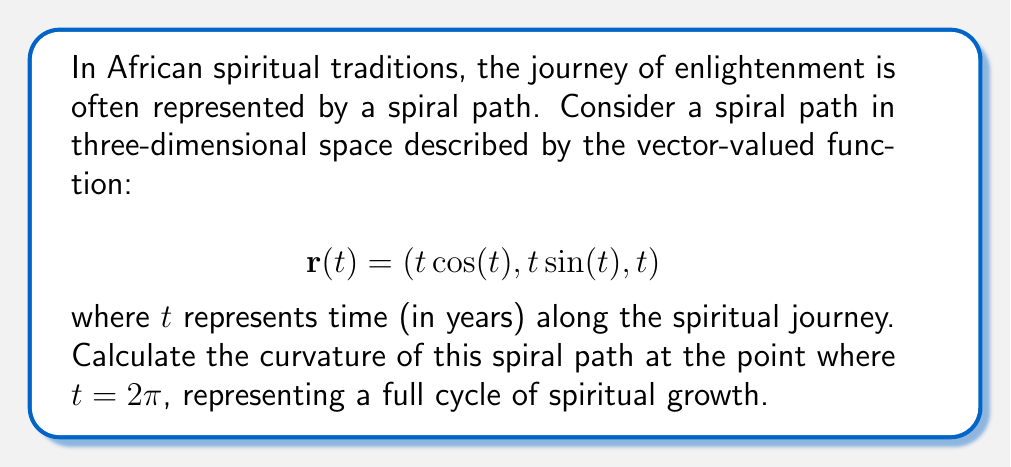Can you answer this question? To calculate the curvature of the spiral path, we'll follow these steps:

1) First, we need to find $\mathbf{r}'(t)$ and $\mathbf{r}''(t)$:

   $$\mathbf{r}'(t) = (\cos(t) - t\sin(t), \sin(t) + t\cos(t), 1)$$
   $$\mathbf{r}''(t) = (-2\sin(t) - t\cos(t), 2\cos(t) - t\sin(t), 0)$$

2) The formula for curvature is:

   $$\kappa = \frac{|\mathbf{r}'(t) \times \mathbf{r}''(t)|}{|\mathbf{r}'(t)|^3}$$

3) Let's calculate $\mathbf{r}'(t) \times \mathbf{r}''(t)$:

   $$\mathbf{r}'(t) \times \mathbf{r}''(t) = \begin{vmatrix} 
   \mathbf{i} & \mathbf{j} & \mathbf{k} \\
   \cos(t) - t\sin(t) & \sin(t) + t\cos(t) & 1 \\
   -2\sin(t) - t\cos(t) & 2\cos(t) - t\sin(t) & 0
   \end{vmatrix}$$

   $$= ((2\cos(t) - t\sin(t)) - (\sin(t) + t\cos(t))(0))\mathbf{i} + ((-2\sin(t) - t\cos(t)) - (\cos(t) - t\sin(t))(0))\mathbf{j} + ((\cos(t) - t\sin(t))(2\cos(t) - t\sin(t)) - (\sin(t) + t\cos(t))(-2\sin(t) - t\cos(t)))\mathbf{k}$$

   $$= (2\cos(t) - t\sin(t))\mathbf{i} + (-2\sin(t) - t\cos(t))\mathbf{j} + (2\cos^2(t) - t\sin(t)\cos(t) + 2\sin^2(t) + t\sin(t)\cos(t))\mathbf{k}$$

   $$= (2\cos(t) - t\sin(t))\mathbf{i} + (-2\sin(t) - t\cos(t))\mathbf{j} + 2\mathbf{k}$$

4) The magnitude of this cross product is:

   $$|\mathbf{r}'(t) \times \mathbf{r}''(t)| = \sqrt{(2\cos(t) - t\sin(t))^2 + (-2\sin(t) - t\cos(t))^2 + 4}$$

5) Now, let's calculate $|\mathbf{r}'(t)|$:

   $$|\mathbf{r}'(t)| = \sqrt{(\cos(t) - t\sin(t))^2 + (\sin(t) + t\cos(t))^2 + 1}$$

6) At $t = 2\pi$:

   $$|\mathbf{r}'(2\pi) \times \mathbf{r}''(2\pi)| = \sqrt{(2 - 2\pi(0))^2 + (0 - 2\pi(1))^2 + 4} = \sqrt{4 + 4\pi^2 + 4} = \sqrt{4\pi^2 + 8}$$

   $$|\mathbf{r}'(2\pi)| = \sqrt{(1 - 2\pi(0))^2 + (0 + 2\pi(1))^2 + 1} = \sqrt{1 + 4\pi^2 + 1} = \sqrt{4\pi^2 + 2}$$

7) Therefore, the curvature at $t = 2\pi$ is:

   $$\kappa = \frac{\sqrt{4\pi^2 + 8}}{(\sqrt{4\pi^2 + 2})^3}$$
Answer: $$\kappa = \frac{\sqrt{4\pi^2 + 8}}{(4\pi^2 + 2)^{3/2}}$$ 